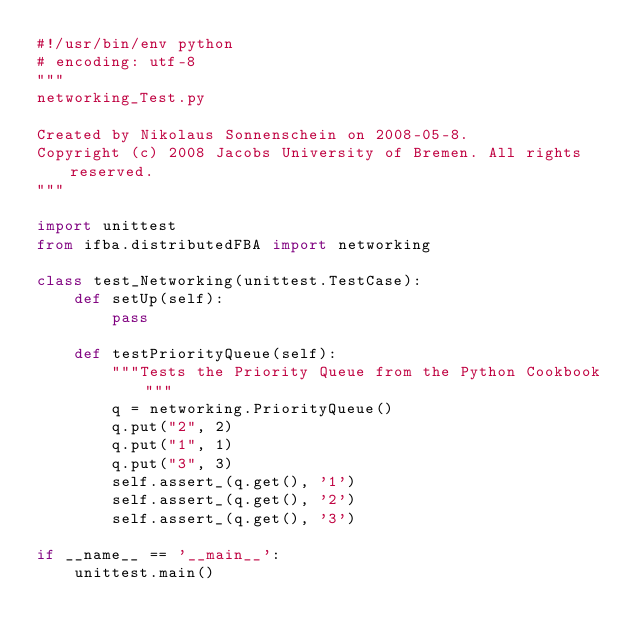Convert code to text. <code><loc_0><loc_0><loc_500><loc_500><_Python_>#!/usr/bin/env python
# encoding: utf-8
"""
networking_Test.py

Created by Nikolaus Sonnenschein on 2008-05-8.
Copyright (c) 2008 Jacobs University of Bremen. All rights reserved.
"""

import unittest
from ifba.distributedFBA import networking

class test_Networking(unittest.TestCase):
    def setUp(self):
        pass
        
    def testPriorityQueue(self):
        """Tests the Priority Queue from the Python Cookbook"""
        q = networking.PriorityQueue()
        q.put("2", 2)
        q.put("1", 1)
        q.put("3", 3)
        self.assert_(q.get(), '1')
        self.assert_(q.get(), '2')
        self.assert_(q.get(), '3')

if __name__ == '__main__':
    unittest.main()</code> 